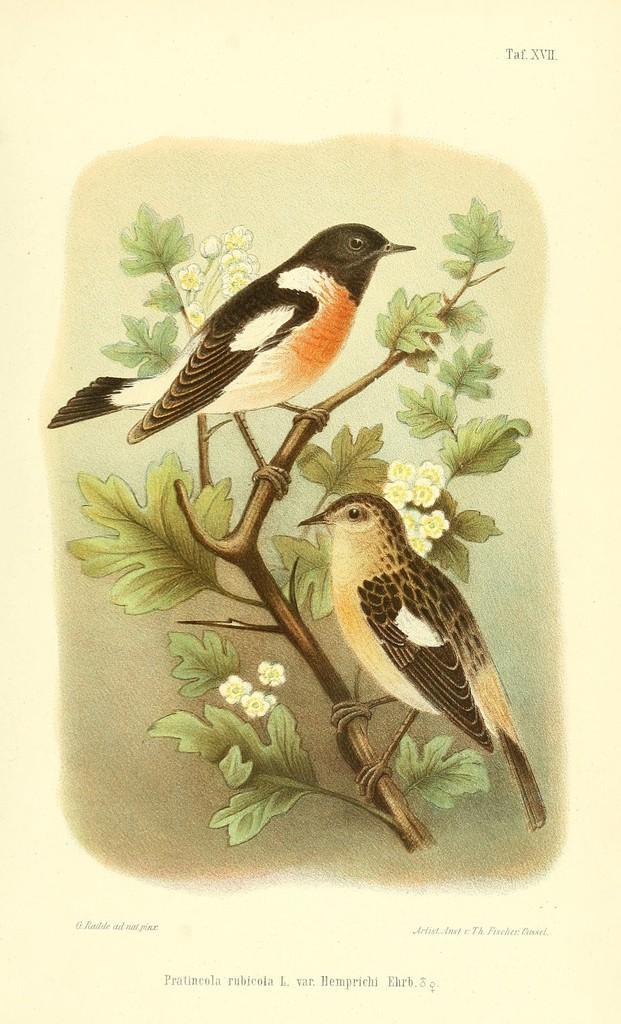In one or two sentences, can you explain what this image depicts? In this image, I can see a paper with a photo of two birds standing on a tree and there are words and roman numbers. 